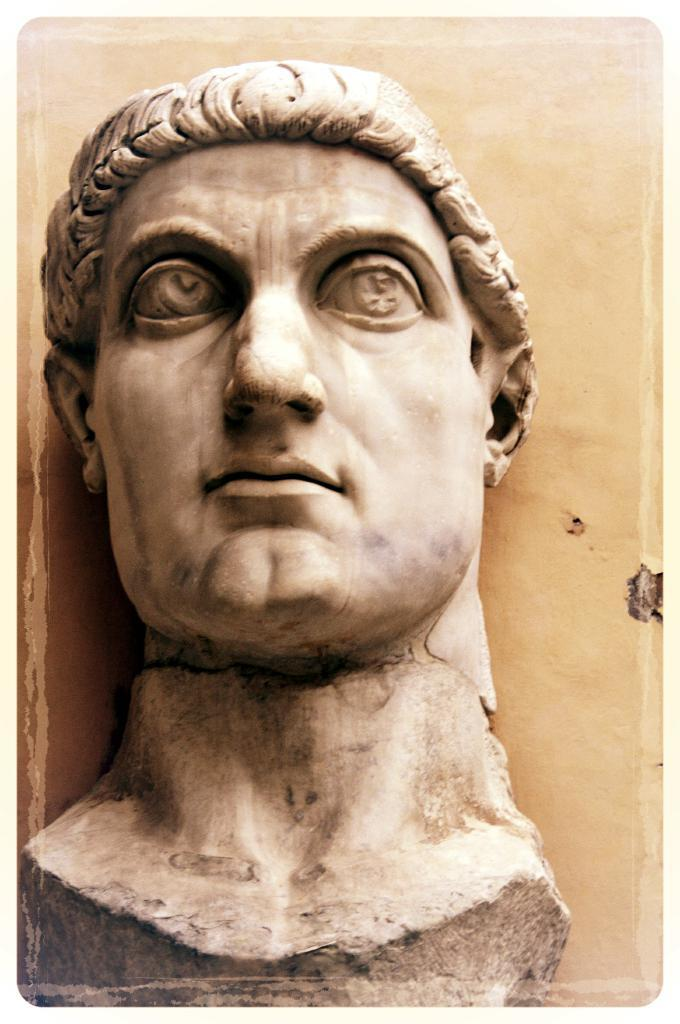What is the main subject of the image? There is a statue of a person in the image. Can you describe the statue in more detail? Unfortunately, the provided facts do not give any additional details about the statue. What might the statue be made of? The material of the statue is not mentioned in the given facts. How many servants are attending to the monkey in the image? There are no servants or monkeys present in the image; it only features a statue of a person. 